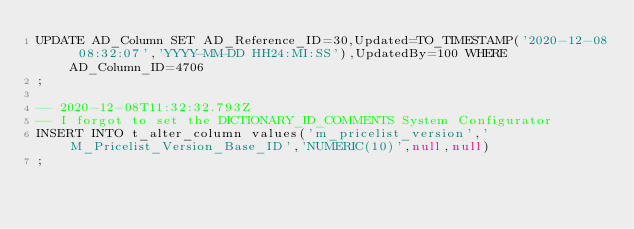<code> <loc_0><loc_0><loc_500><loc_500><_SQL_>UPDATE AD_Column SET AD_Reference_ID=30,Updated=TO_TIMESTAMP('2020-12-08 08:32:07','YYYY-MM-DD HH24:MI:SS'),UpdatedBy=100 WHERE AD_Column_ID=4706
;

-- 2020-12-08T11:32:32.793Z
-- I forgot to set the DICTIONARY_ID_COMMENTS System Configurator
INSERT INTO t_alter_column values('m_pricelist_version','M_Pricelist_Version_Base_ID','NUMERIC(10)',null,null)
;

</code> 